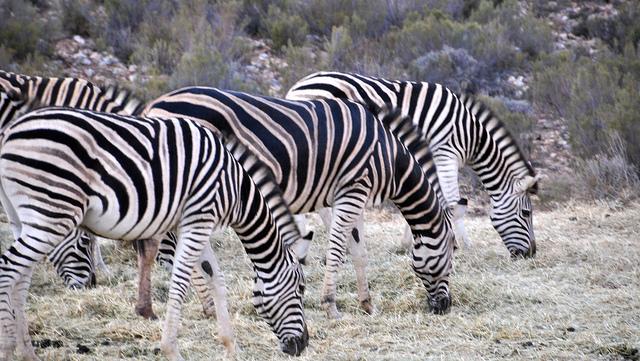Does any of the grass have butterflies on the blades?
Give a very brief answer. No. Could this be a wild-game preserve?
Quick response, please. Yes. How many animals are in this picture?
Concise answer only. 4. Are these race horses?
Keep it brief. No. 